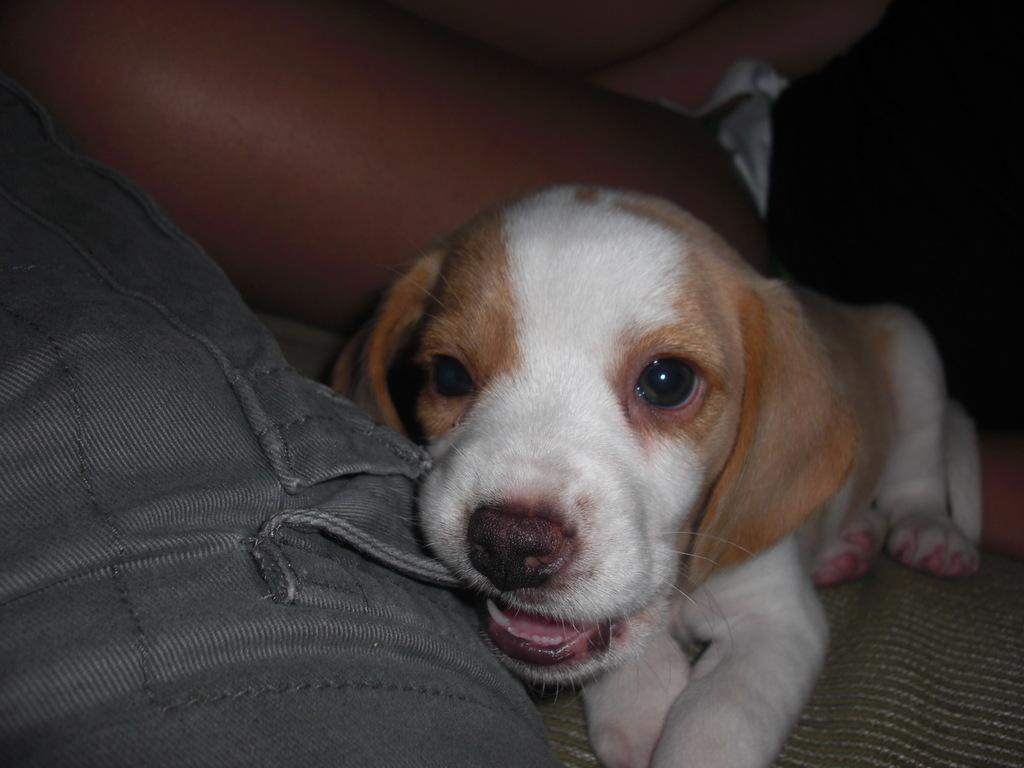What animal is present in the image? There is a dog in the image. What is the dog doing in the image? The dog is lying down. Is there anyone else in the image besides the dog? Yes, there is a person near the dog. How many beans are scattered around the dog in the image? There are no beans present in the image. What type of self-care activity is the person near the dog engaged in? The image does not provide information about any self-care activities being performed by the person near the dog. 